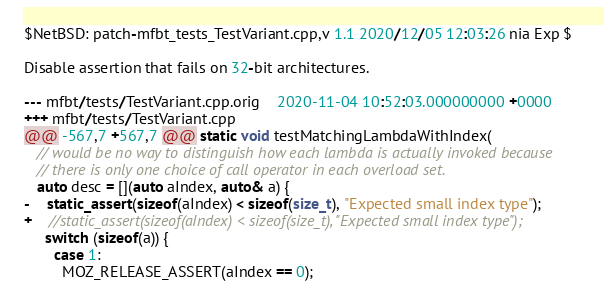<code> <loc_0><loc_0><loc_500><loc_500><_C++_>$NetBSD: patch-mfbt_tests_TestVariant.cpp,v 1.1 2020/12/05 12:03:26 nia Exp $

Disable assertion that fails on 32-bit architectures.

--- mfbt/tests/TestVariant.cpp.orig	2020-11-04 10:52:03.000000000 +0000
+++ mfbt/tests/TestVariant.cpp
@@ -567,7 +567,7 @@ static void testMatchingLambdaWithIndex(
   // would be no way to distinguish how each lambda is actually invoked because
   // there is only one choice of call operator in each overload set.
   auto desc = [](auto aIndex, auto& a) {
-    static_assert(sizeof(aIndex) < sizeof(size_t), "Expected small index type");
+    //static_assert(sizeof(aIndex) < sizeof(size_t), "Expected small index type");
     switch (sizeof(a)) {
       case 1:
         MOZ_RELEASE_ASSERT(aIndex == 0);
</code> 